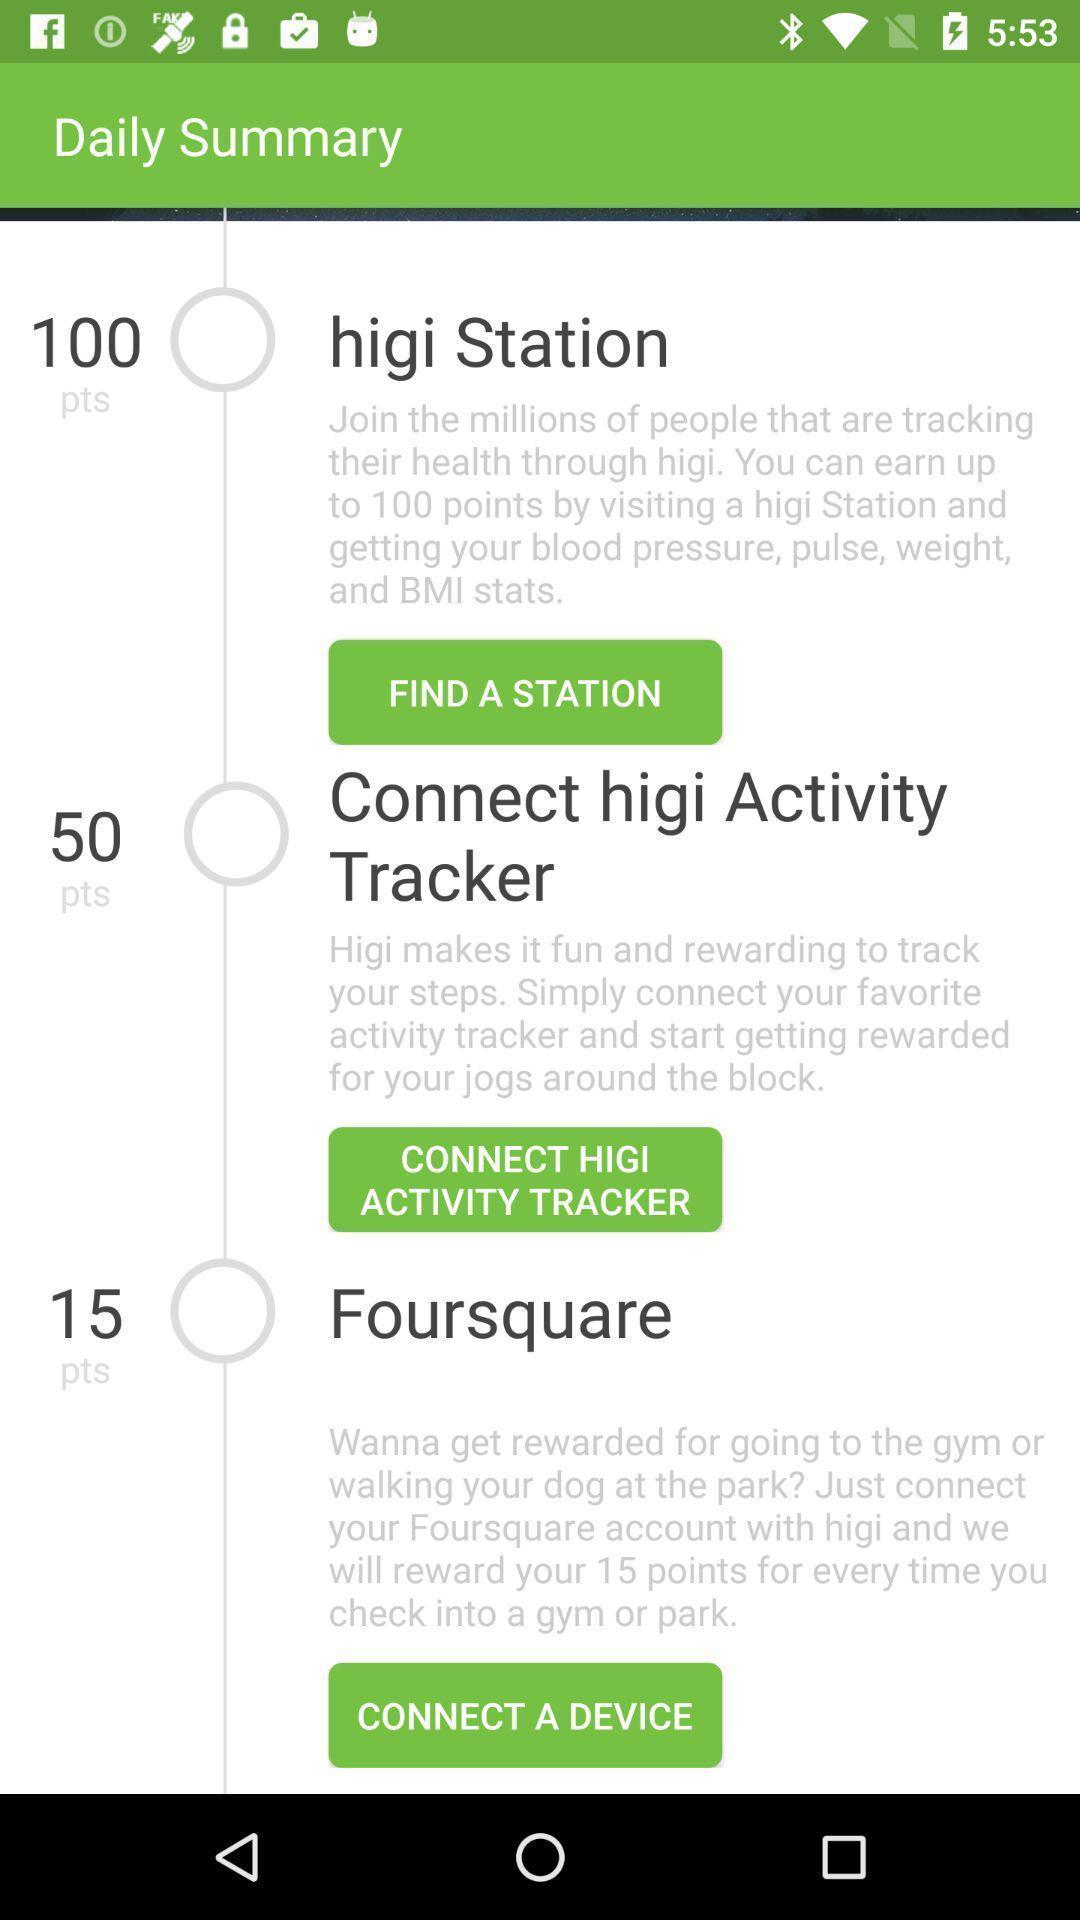Provide a description of this screenshot. Screen page of a health tracker app. 